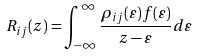Convert formula to latex. <formula><loc_0><loc_0><loc_500><loc_500>R _ { i j } ( z ) = \int _ { - \infty } ^ { \infty } \frac { \rho _ { i j } ( \varepsilon ) f ( \varepsilon ) } { z - \varepsilon } d \varepsilon</formula> 